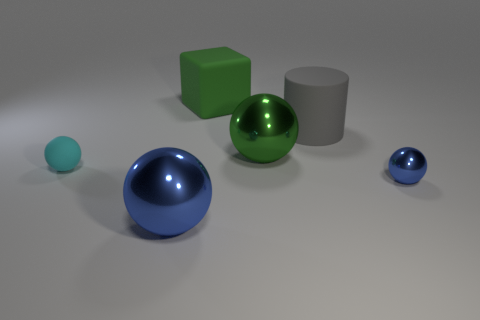What materials are depicted in the objects shown in the image? The objects in the image appear to have different materials. The spheres and the cube look like they have a smooth, reflective surface, suggesting they could be made of metal or plastic with a glossy finish. The cylinder looks matte, possibly like stone or clay. 